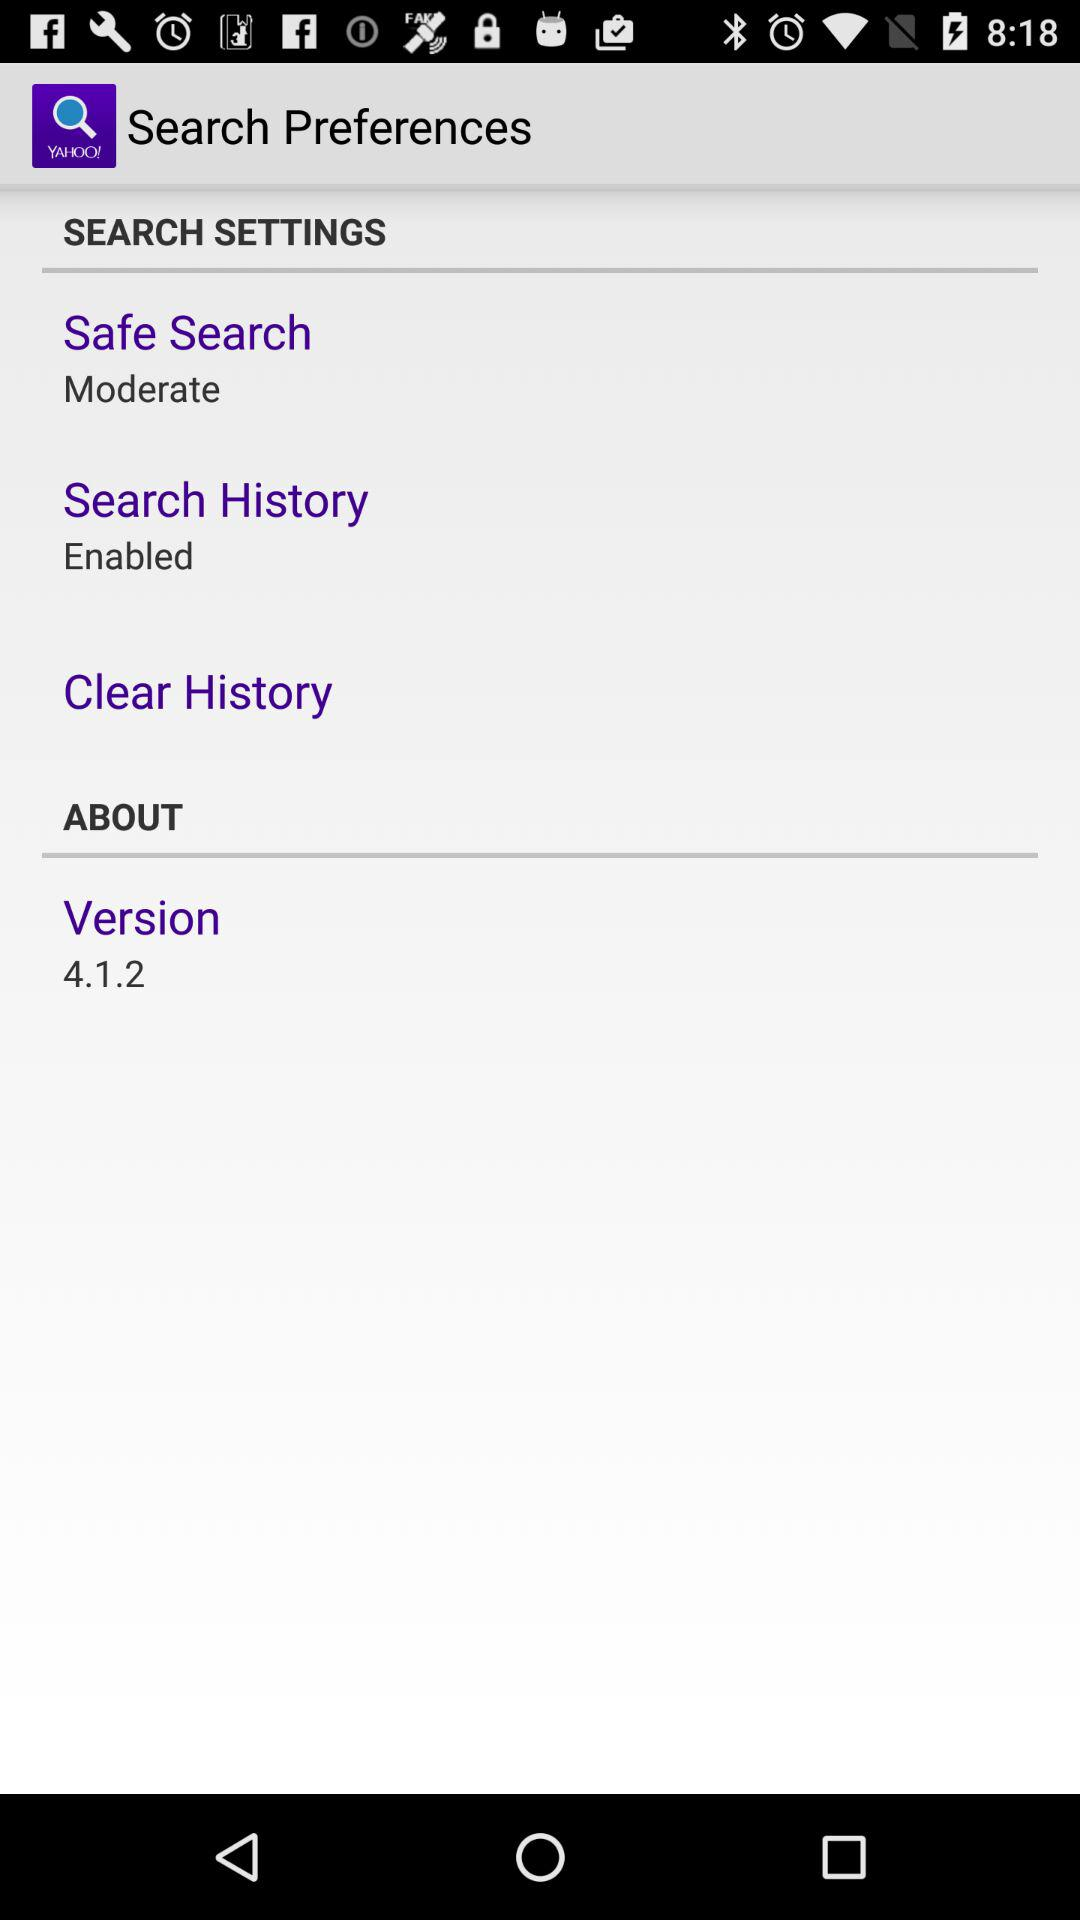What is the version number of the app?
Answer the question using a single word or phrase. 4.1.2 